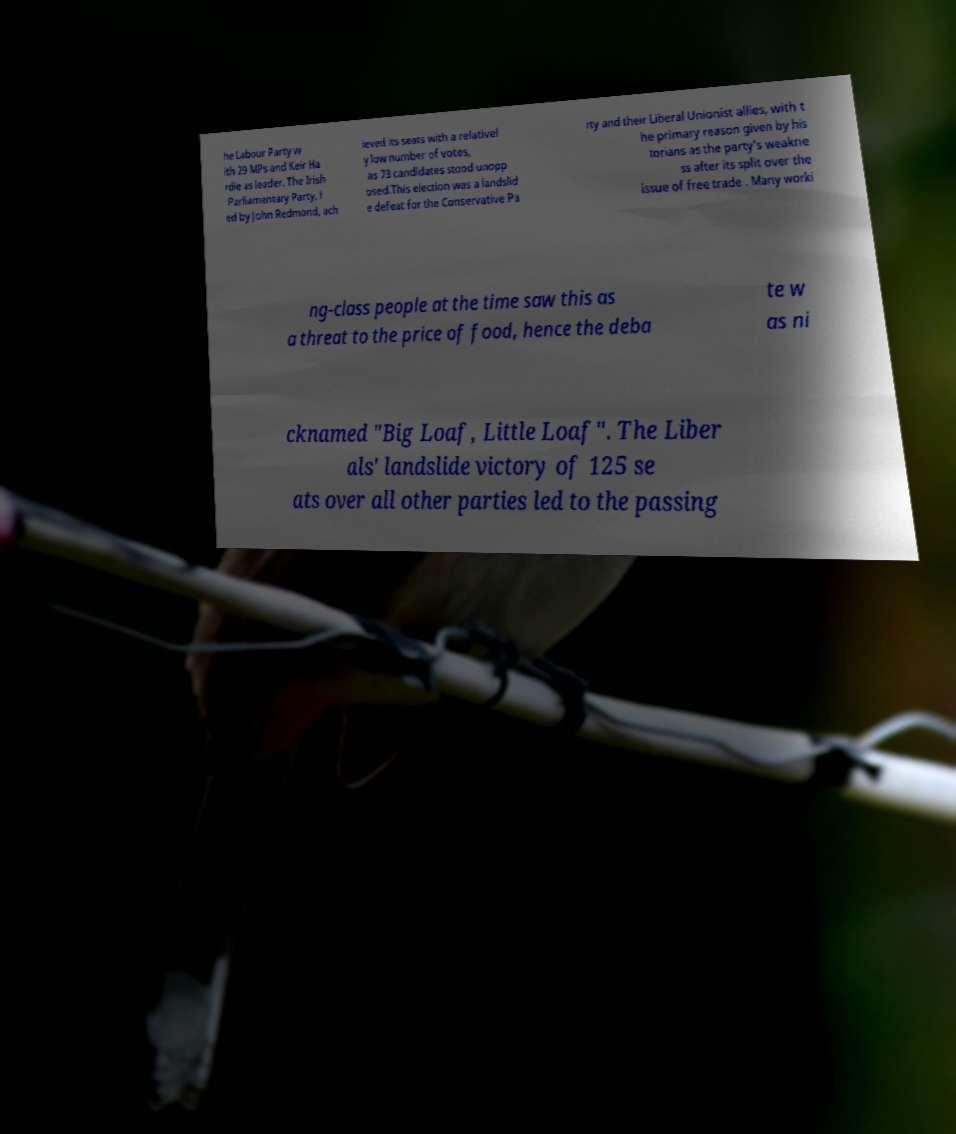What messages or text are displayed in this image? I need them in a readable, typed format. he Labour Party w ith 29 MPs and Keir Ha rdie as leader. The Irish Parliamentary Party, l ed by John Redmond, ach ieved its seats with a relativel y low number of votes, as 73 candidates stood unopp osed.This election was a landslid e defeat for the Conservative Pa rty and their Liberal Unionist allies, with t he primary reason given by his torians as the party's weakne ss after its split over the issue of free trade . Many worki ng-class people at the time saw this as a threat to the price of food, hence the deba te w as ni cknamed "Big Loaf, Little Loaf". The Liber als' landslide victory of 125 se ats over all other parties led to the passing 